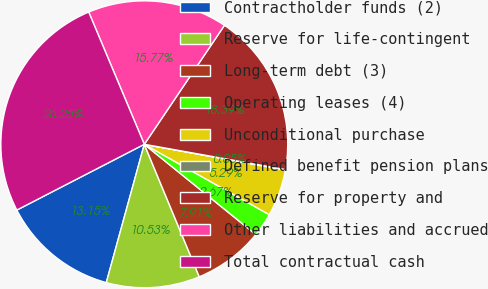Convert chart to OTSL. <chart><loc_0><loc_0><loc_500><loc_500><pie_chart><fcel>Contractholder funds (2)<fcel>Reserve for life-contingent<fcel>Long-term debt (3)<fcel>Operating leases (4)<fcel>Unconditional purchase<fcel>Defined benefit pension plans<fcel>Reserve for property and<fcel>Other liabilities and accrued<fcel>Total contractual cash<nl><fcel>13.15%<fcel>10.53%<fcel>7.91%<fcel>2.67%<fcel>5.29%<fcel>0.05%<fcel>18.39%<fcel>15.77%<fcel>26.25%<nl></chart> 